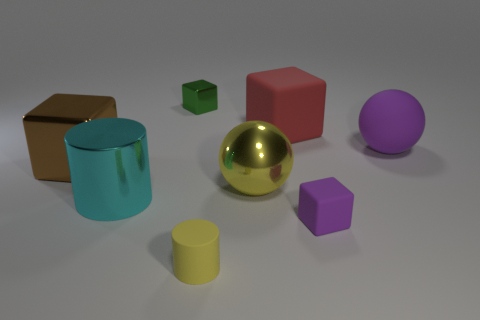Subtract all small green cubes. How many cubes are left? 3 Add 1 big brown cubes. How many objects exist? 9 Subtract 3 blocks. How many blocks are left? 1 Subtract all yellow cylinders. How many cylinders are left? 1 Subtract all cylinders. How many objects are left? 6 Subtract 0 gray cylinders. How many objects are left? 8 Subtract all blue blocks. Subtract all cyan cylinders. How many blocks are left? 4 Subtract all small yellow matte objects. Subtract all cubes. How many objects are left? 3 Add 4 purple matte objects. How many purple matte objects are left? 6 Add 3 big purple matte balls. How many big purple matte balls exist? 4 